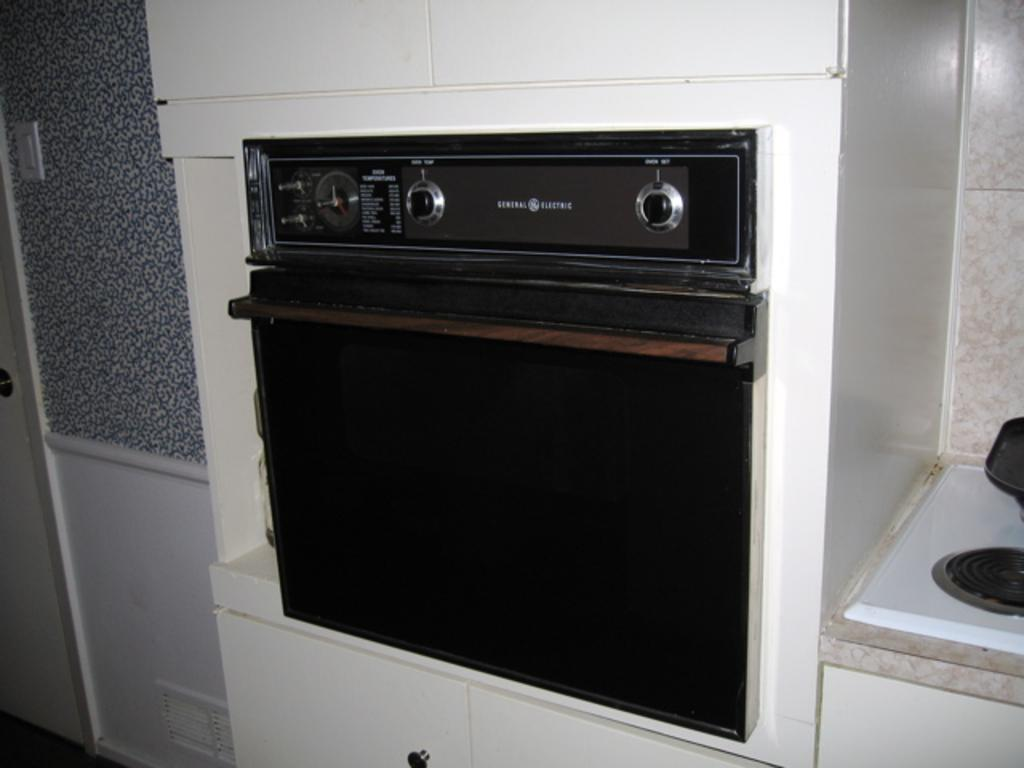What appliance is visible in the image? There is a microwave oven in the image. Where is the microwave oven located in relation to other objects? The microwave oven is fixed between cupboards. What can be seen on the left side of the image? There is a door on the left side of the image. What type of surface is visible on the right side of the image? There are tiles on the right side of the image. Where is the playground located in the image? There is no playground present in the image. What type of pleasure can be derived from the microwave oven in the image? The image does not convey any information about the pleasure derived from the microwave oven; it simply shows the appliance's location and appearance. 